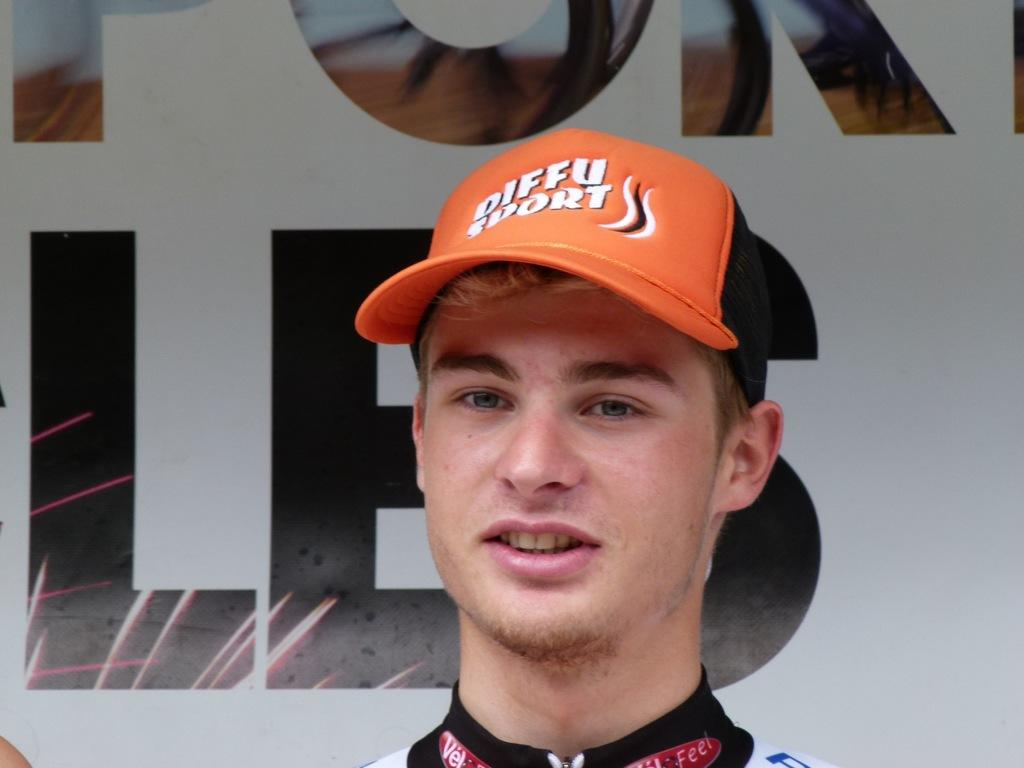<image>
Give a short and clear explanation of the subsequent image. Man wearing an orange Diffu Sports cap looking at something. 